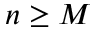<formula> <loc_0><loc_0><loc_500><loc_500>n \geq M</formula> 